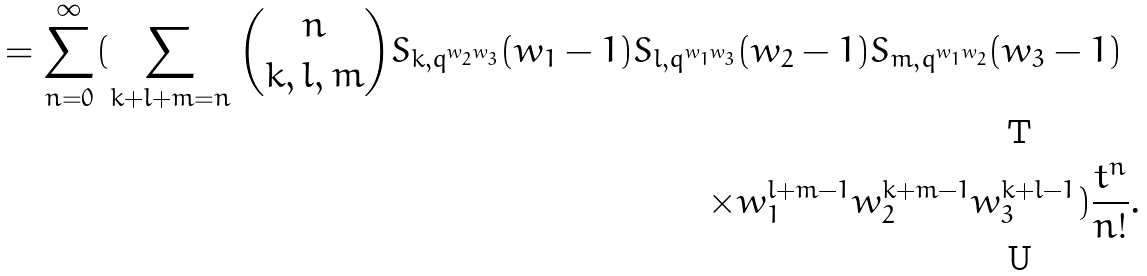<formula> <loc_0><loc_0><loc_500><loc_500>= \sum _ { n = 0 } ^ { \infty } ( \sum _ { k + l + m = n } \binom { n } { k , l , m } S _ { k , q ^ { w _ { 2 } w _ { 3 } } } ( w _ { 1 } - 1 ) S _ { l , q ^ { w _ { 1 } w _ { 3 } } } & ( w _ { 2 } - 1 ) S _ { m , q ^ { w _ { 1 } w _ { 2 } } } ( w _ { 3 } - 1 ) \\ \times & w _ { 1 } ^ { l + m - 1 } w _ { 2 } ^ { k + m - 1 } w _ { 3 } ^ { k + l - 1 } ) \frac { t ^ { n } } { n ! } .</formula> 